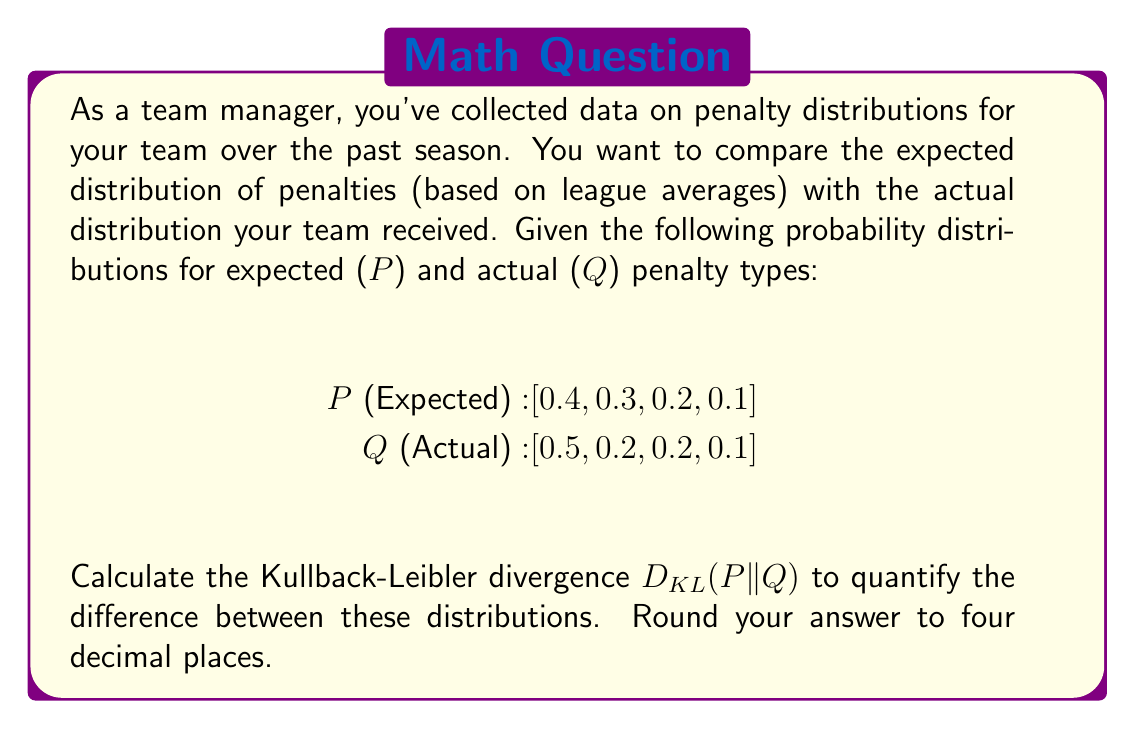Teach me how to tackle this problem. To solve this problem, we'll use the Kullback-Leibler divergence formula:

$$D_{KL}(P||Q) = \sum_{i} P(i) \log\left(\frac{P(i)}{Q(i)}\right)$$

Let's calculate each term of the sum:

1. For i = 1:
   $P(1) = 0.4, Q(1) = 0.5$
   $0.4 \log\left(\frac{0.4}{0.5}\right) = 0.4 \log(0.8) = 0.4 \times (-0.09691) = -0.03876$

2. For i = 2:
   $P(2) = 0.3, Q(2) = 0.2$
   $0.3 \log\left(\frac{0.3}{0.2}\right) = 0.3 \log(1.5) = 0.3 \times 0.17609 = 0.05283$

3. For i = 3:
   $P(3) = 0.2, Q(3) = 0.2$
   $0.2 \log\left(\frac{0.2}{0.2}\right) = 0.2 \log(1) = 0$

4. For i = 4:
   $P(4) = 0.1, Q(4) = 0.1$
   $0.1 \log\left(\frac{0.1}{0.1}\right) = 0.1 \log(1) = 0$

Now, sum all these terms:

$$D_{KL}(P||Q) = (-0.03876) + 0.05283 + 0 + 0 = 0.01407$$

Rounding to four decimal places, we get 0.0141.
Answer: 0.0141 